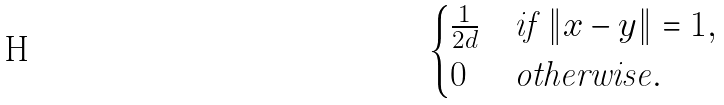Convert formula to latex. <formula><loc_0><loc_0><loc_500><loc_500>\begin{cases} \frac { 1 } { 2 d } & \text {if } \| x - y \| = 1 , \\ 0 & \text {otherwise} . \end{cases}</formula> 